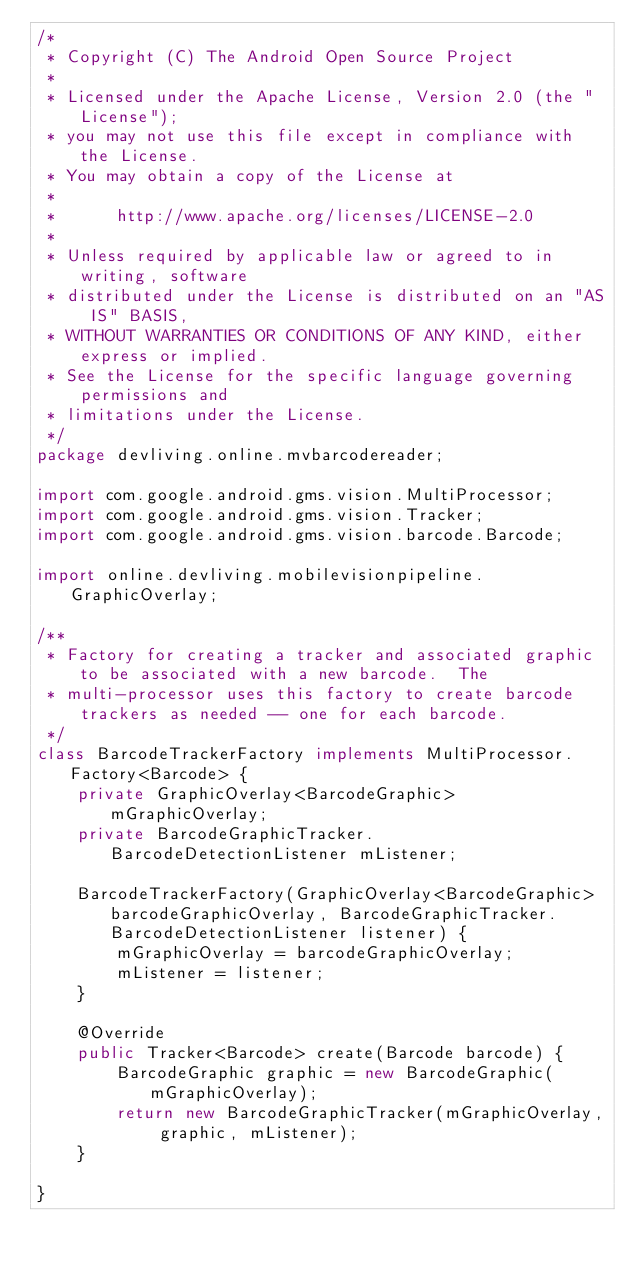Convert code to text. <code><loc_0><loc_0><loc_500><loc_500><_Java_>/*
 * Copyright (C) The Android Open Source Project
 *
 * Licensed under the Apache License, Version 2.0 (the "License");
 * you may not use this file except in compliance with the License.
 * You may obtain a copy of the License at
 *
 *      http://www.apache.org/licenses/LICENSE-2.0
 *
 * Unless required by applicable law or agreed to in writing, software
 * distributed under the License is distributed on an "AS IS" BASIS,
 * WITHOUT WARRANTIES OR CONDITIONS OF ANY KIND, either express or implied.
 * See the License for the specific language governing permissions and
 * limitations under the License.
 */
package devliving.online.mvbarcodereader;

import com.google.android.gms.vision.MultiProcessor;
import com.google.android.gms.vision.Tracker;
import com.google.android.gms.vision.barcode.Barcode;

import online.devliving.mobilevisionpipeline.GraphicOverlay;

/**
 * Factory for creating a tracker and associated graphic to be associated with a new barcode.  The
 * multi-processor uses this factory to create barcode trackers as needed -- one for each barcode.
 */
class BarcodeTrackerFactory implements MultiProcessor.Factory<Barcode> {
    private GraphicOverlay<BarcodeGraphic> mGraphicOverlay;
    private BarcodeGraphicTracker.BarcodeDetectionListener mListener;

    BarcodeTrackerFactory(GraphicOverlay<BarcodeGraphic> barcodeGraphicOverlay, BarcodeGraphicTracker.BarcodeDetectionListener listener) {
        mGraphicOverlay = barcodeGraphicOverlay;
        mListener = listener;
    }

    @Override
    public Tracker<Barcode> create(Barcode barcode) {
        BarcodeGraphic graphic = new BarcodeGraphic(mGraphicOverlay);
        return new BarcodeGraphicTracker(mGraphicOverlay, graphic, mListener);
    }

}

</code> 